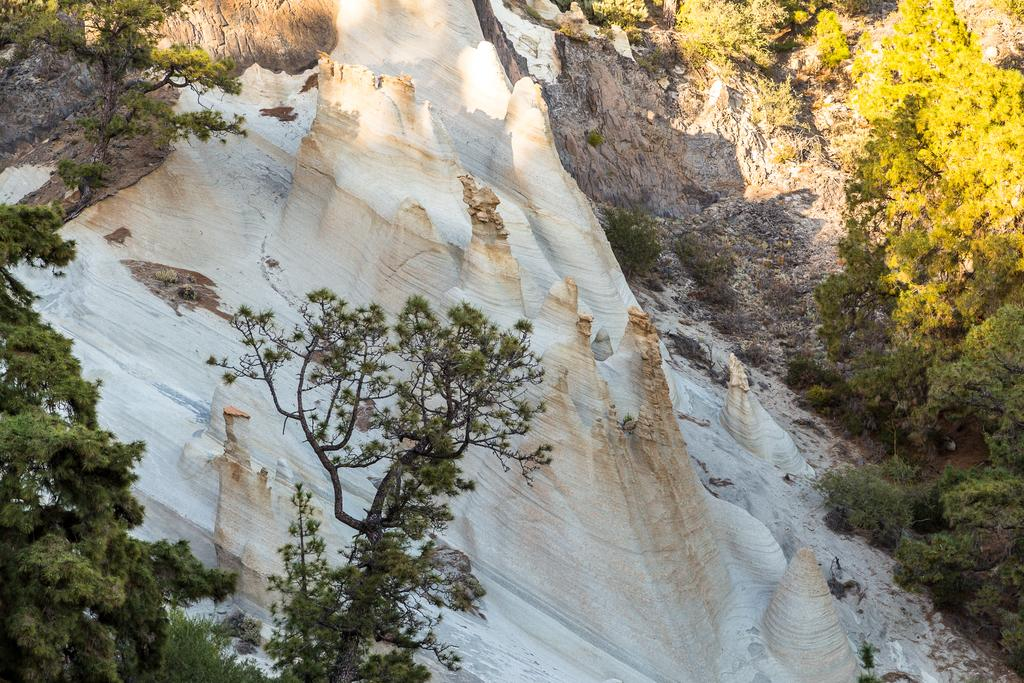What is the main geological feature in the image? There is an outcrop on the surface in the image. What type of vegetation can be seen in the image? There are trees in the image. What scientific experiment is being conducted with the duck and umbrella in the image? There is no duck or umbrella present in the image, and therefore no such experiment can be observed. 